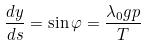Convert formula to latex. <formula><loc_0><loc_0><loc_500><loc_500>\frac { d y } { d s } = \sin \varphi = \frac { \lambda _ { 0 } g p } { T }</formula> 